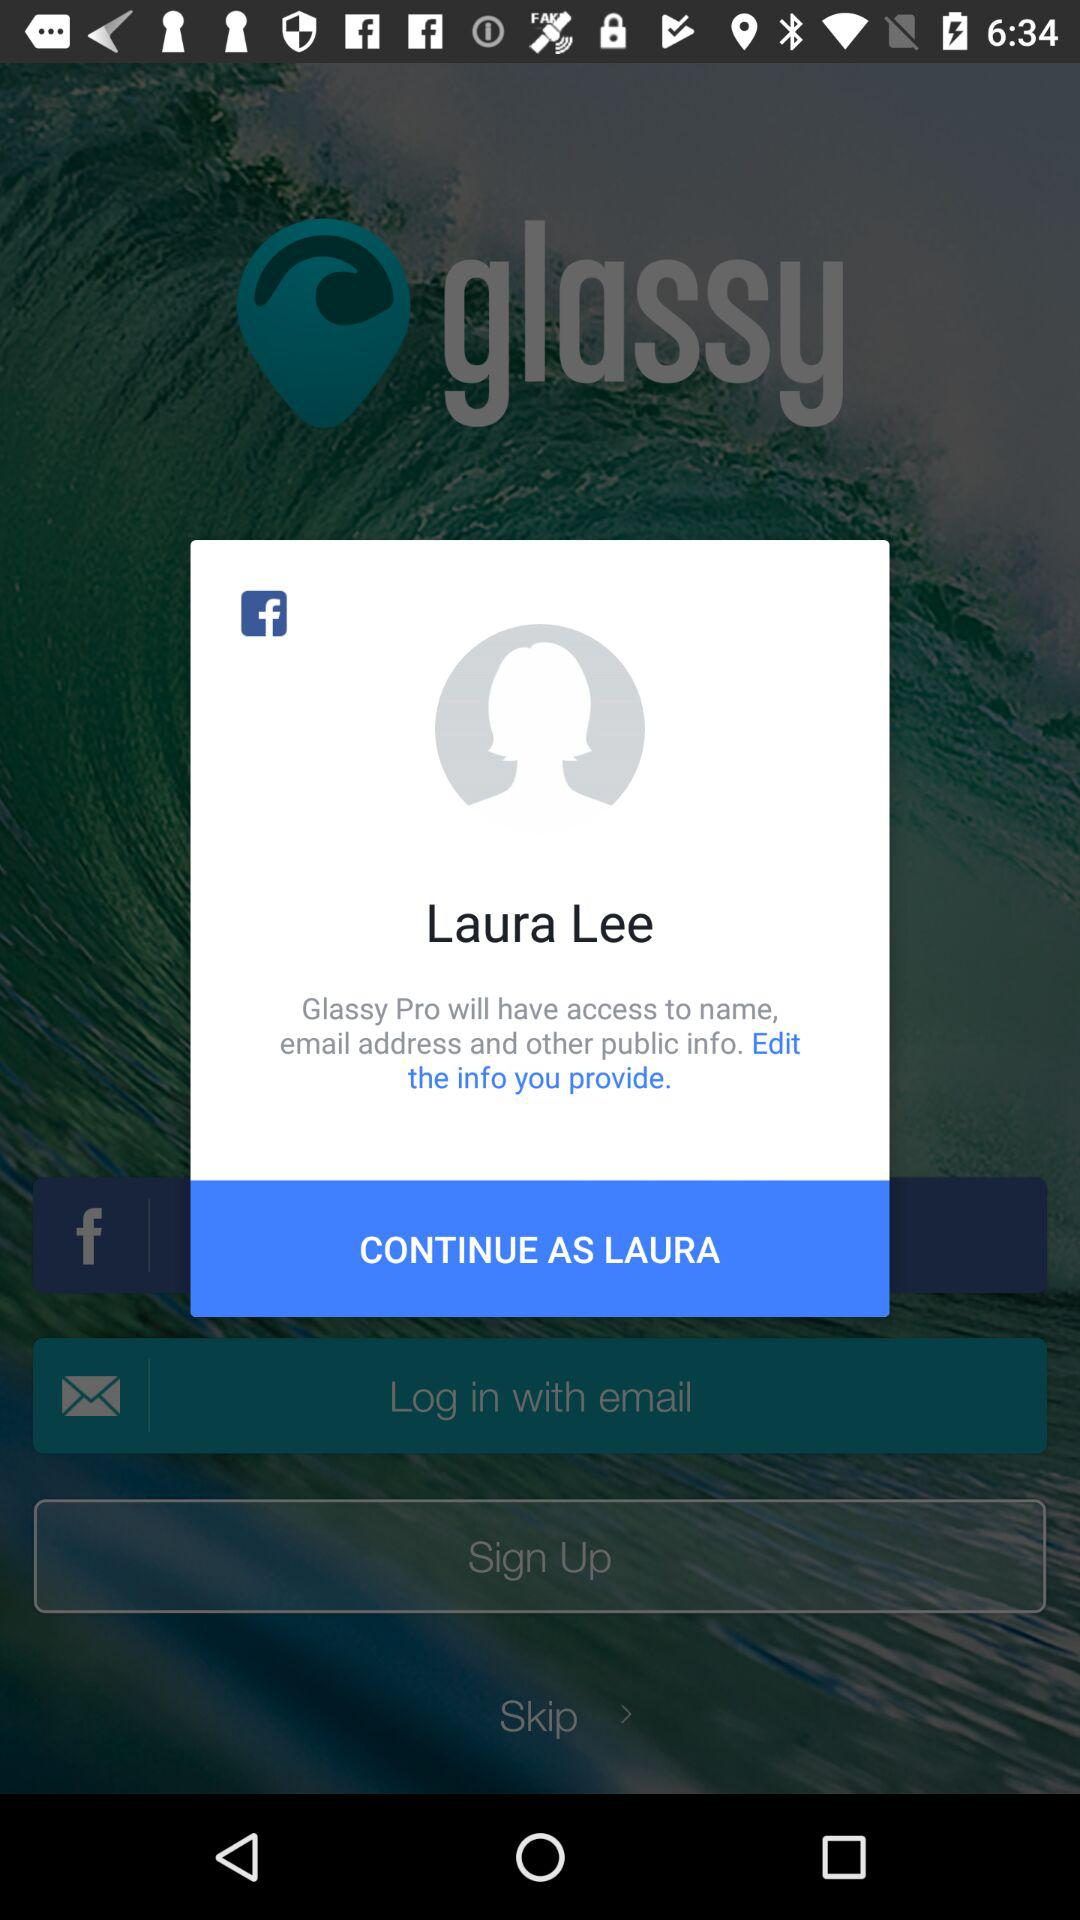What is the application name that wants access? The application name is "Glassy Pro". 